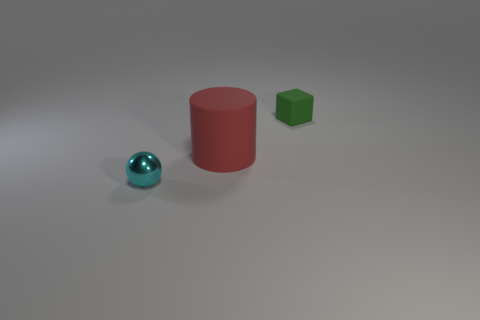Add 2 cyan objects. How many objects exist? 5 Subtract all cylinders. How many objects are left? 2 Subtract all balls. Subtract all spheres. How many objects are left? 1 Add 2 small balls. How many small balls are left? 3 Add 3 red objects. How many red objects exist? 4 Subtract 0 blue blocks. How many objects are left? 3 